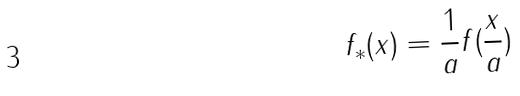<formula> <loc_0><loc_0><loc_500><loc_500>f _ { * } ( x ) = \frac { 1 } { a } f ( \frac { x } { a } )</formula> 